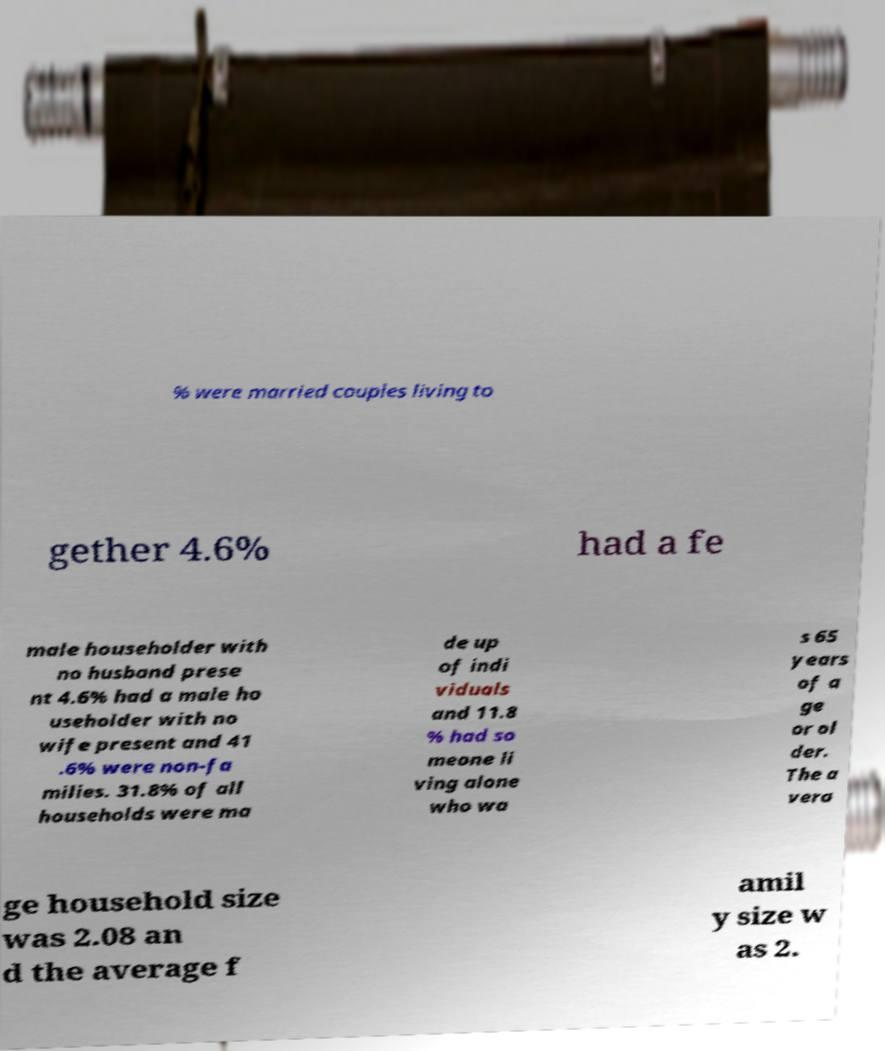Could you assist in decoding the text presented in this image and type it out clearly? % were married couples living to gether 4.6% had a fe male householder with no husband prese nt 4.6% had a male ho useholder with no wife present and 41 .6% were non-fa milies. 31.8% of all households were ma de up of indi viduals and 11.8 % had so meone li ving alone who wa s 65 years of a ge or ol der. The a vera ge household size was 2.08 an d the average f amil y size w as 2. 